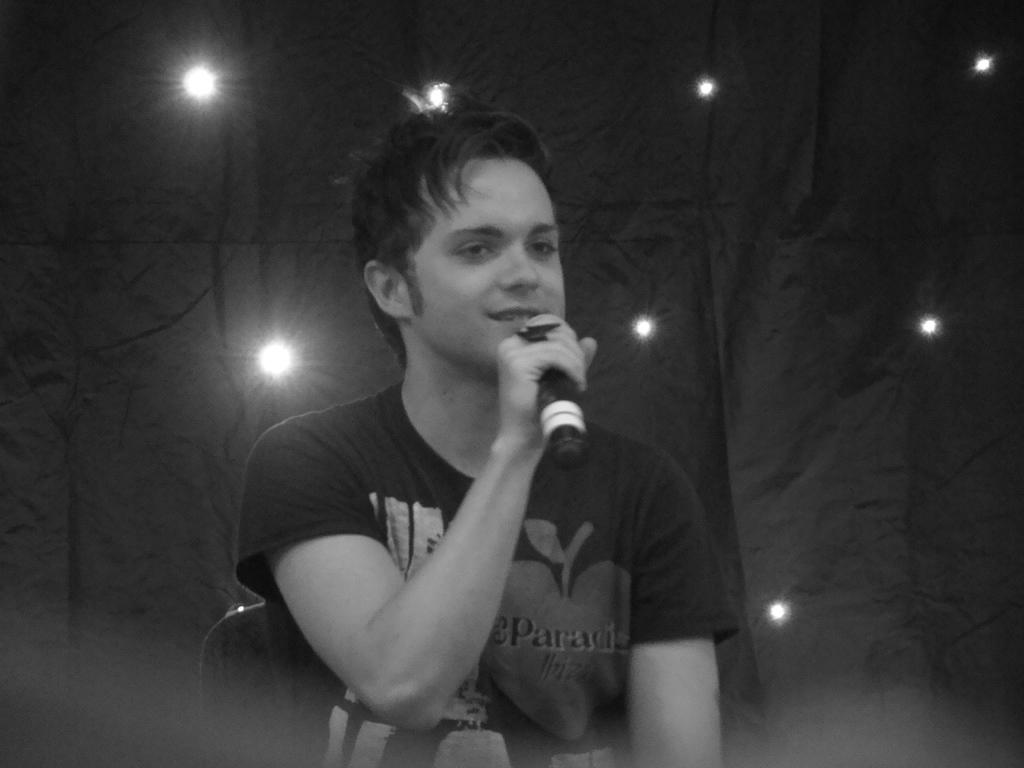Who is the person in the image? There is a man in the image. What is the man wearing? The man is wearing a black t-shirt. What is the man doing in the image? The man is sitting on a chair and talking. What is the man holding in his hand? The man is holding a mic in his hand. What can be seen in the background of the image? There is a black cloth in the background with small lights on it. How many legs does the clam have in the image? There is no clam present in the image. What type of hand is holding the mic in the image? The man's hand is holding the mic in the image, and there is no mention of any other type of hand. 